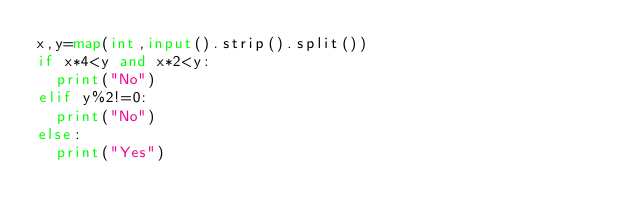<code> <loc_0><loc_0><loc_500><loc_500><_Python_>x,y=map(int,input().strip().split())
if x*4<y and x*2<y:
  print("No")
elif y%2!=0:
  print("No")
else:
  print("Yes")
</code> 